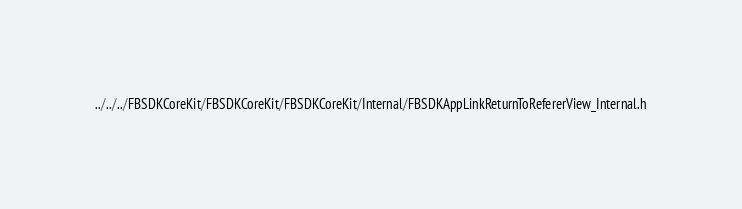Convert code to text. <code><loc_0><loc_0><loc_500><loc_500><_C_>../../../FBSDKCoreKit/FBSDKCoreKit/FBSDKCoreKit/Internal/FBSDKAppLinkReturnToRefererView_Internal.h</code> 